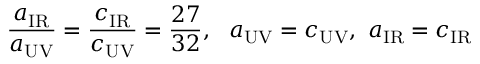Convert formula to latex. <formula><loc_0><loc_0><loc_500><loc_500>\frac { a _ { I R } } { a _ { U V } } = \frac { c _ { I R } } { c _ { U V } } = \frac { 2 7 } { 3 2 } , a _ { U V } = c _ { U V } , a _ { I R } = c _ { I R }</formula> 